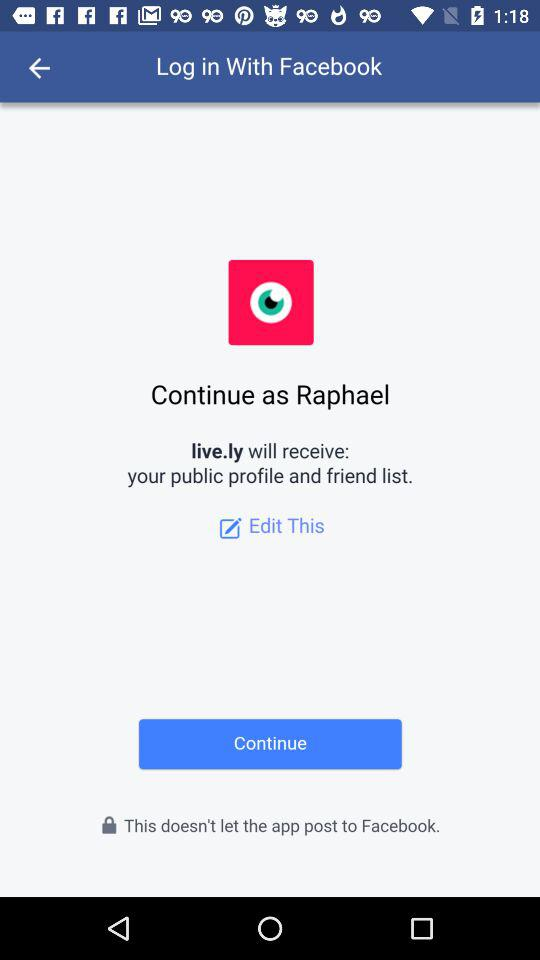What is the login name? The login name is Raphael. 